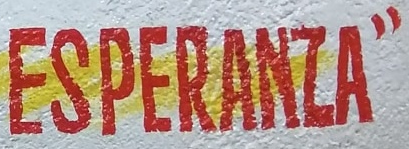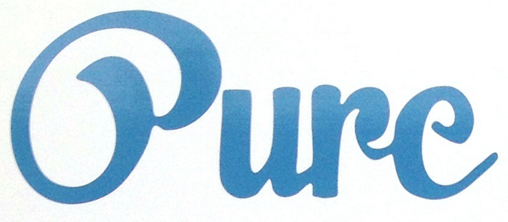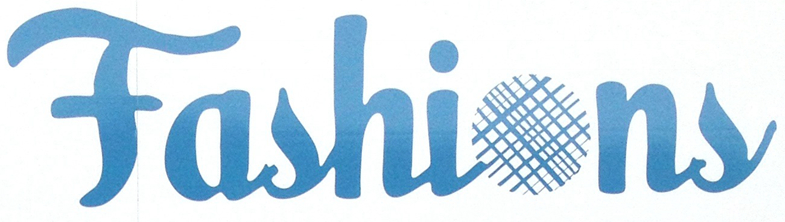Transcribe the words shown in these images in order, separated by a semicolon. ESPERANZA"; Oure; Fashions 